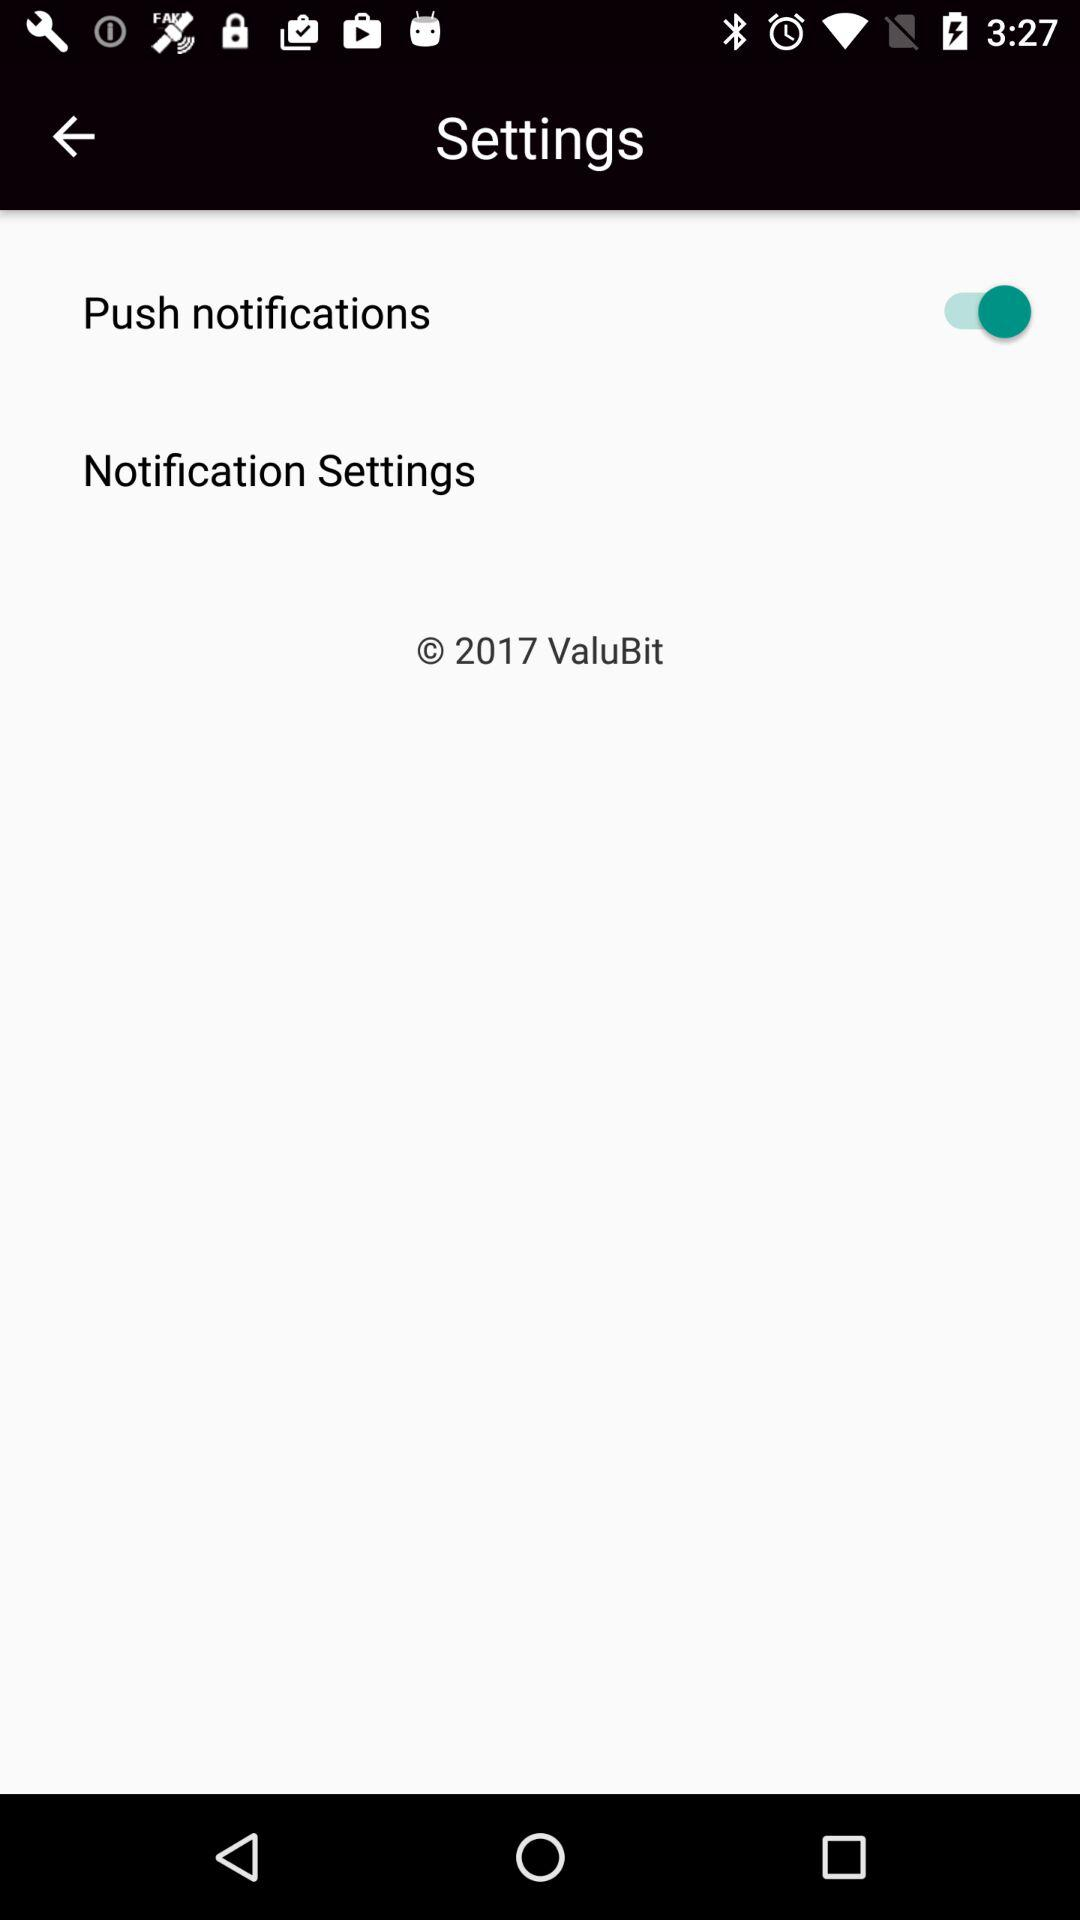What is the status of "Push notifications"? The status is "on". 